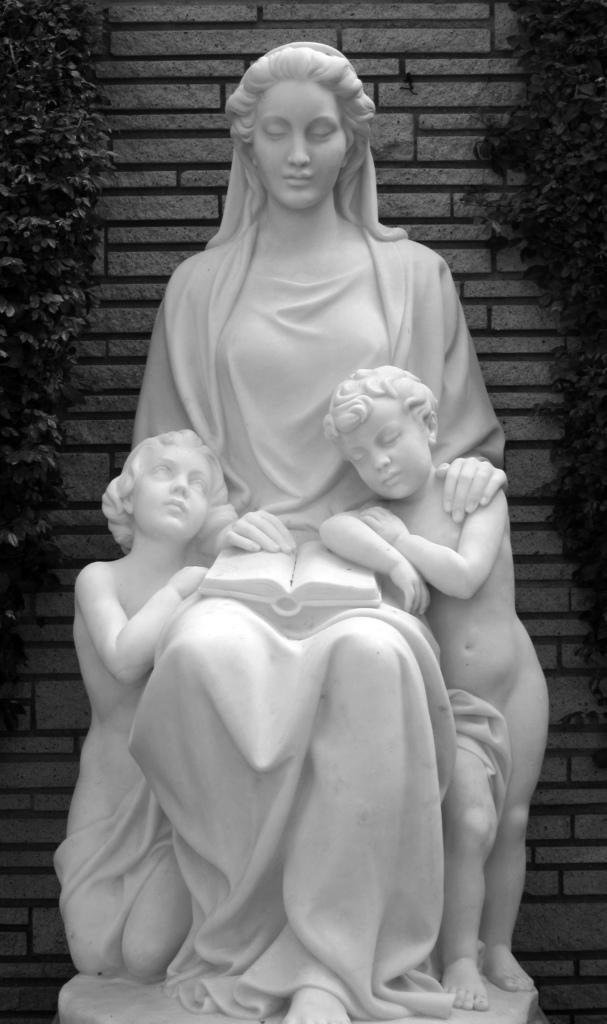What is the color scheme of the image? The image is black and white. What is the main subject in the center of the image? There is a statue in the center of the image. What can be seen in the background of the image? There is a wall and trees in the background of the image. What type of degree does the owl in the image have? There is no owl present in the image, so it is not possible to determine what type of degree it might have. 